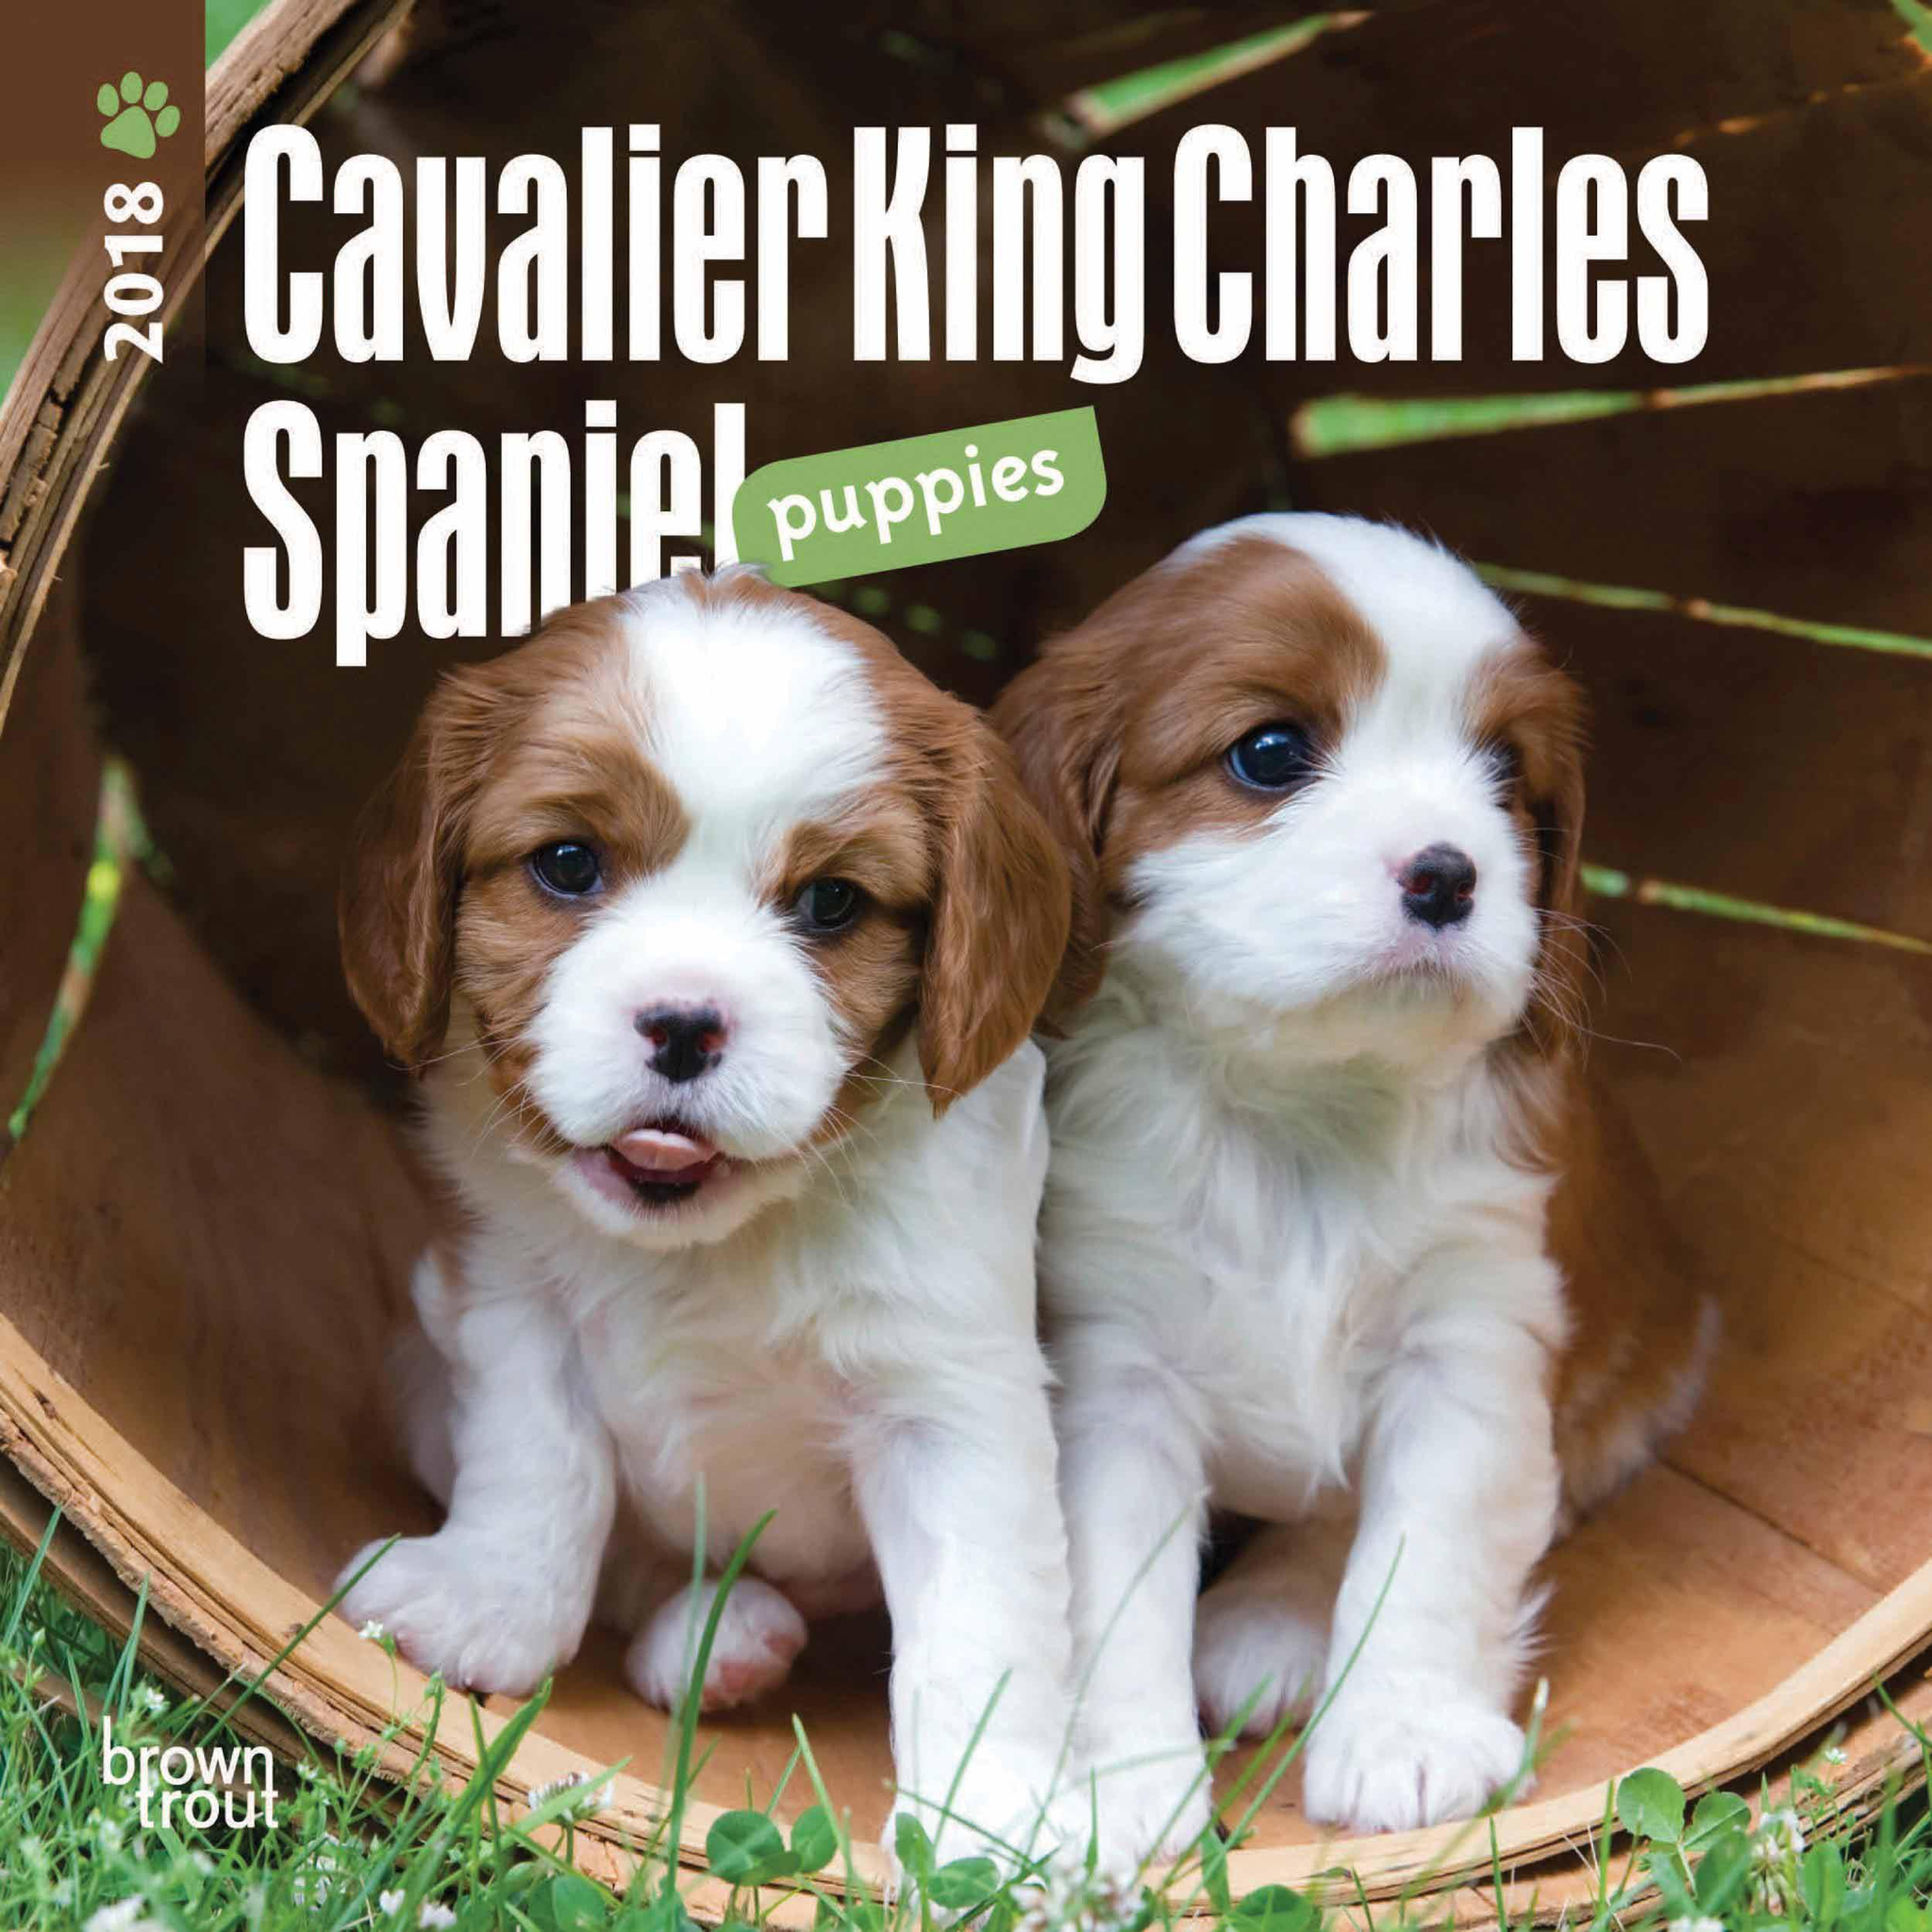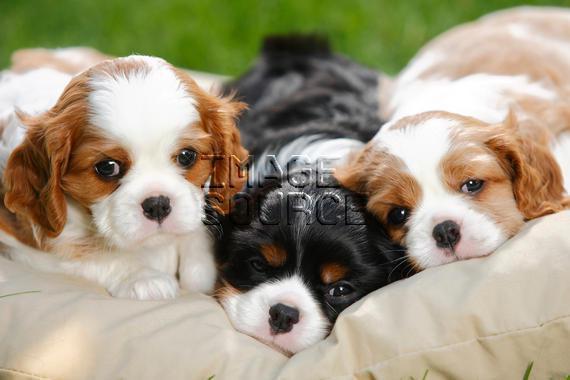The first image is the image on the left, the second image is the image on the right. Given the left and right images, does the statement "There are at most two dogs." hold true? Answer yes or no. No. The first image is the image on the left, the second image is the image on the right. Analyze the images presented: Is the assertion "There are exactly two Cavalier King Charles puppies on the pair of images." valid? Answer yes or no. No. 